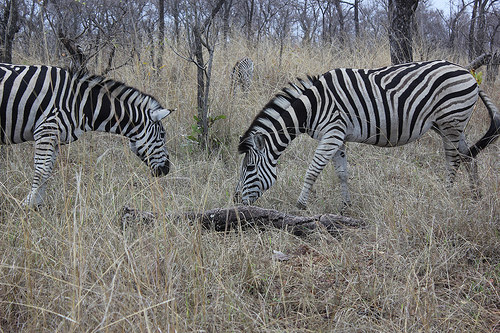Can you tell me about the environment where these zebras are? The zebras are in a savanna-like environment with dry, golden brown grass typical of regions that experience seasonal drought. The sparse trees and shrubs in the background suggest a fairly open landscape, which is common in African grasslands. 